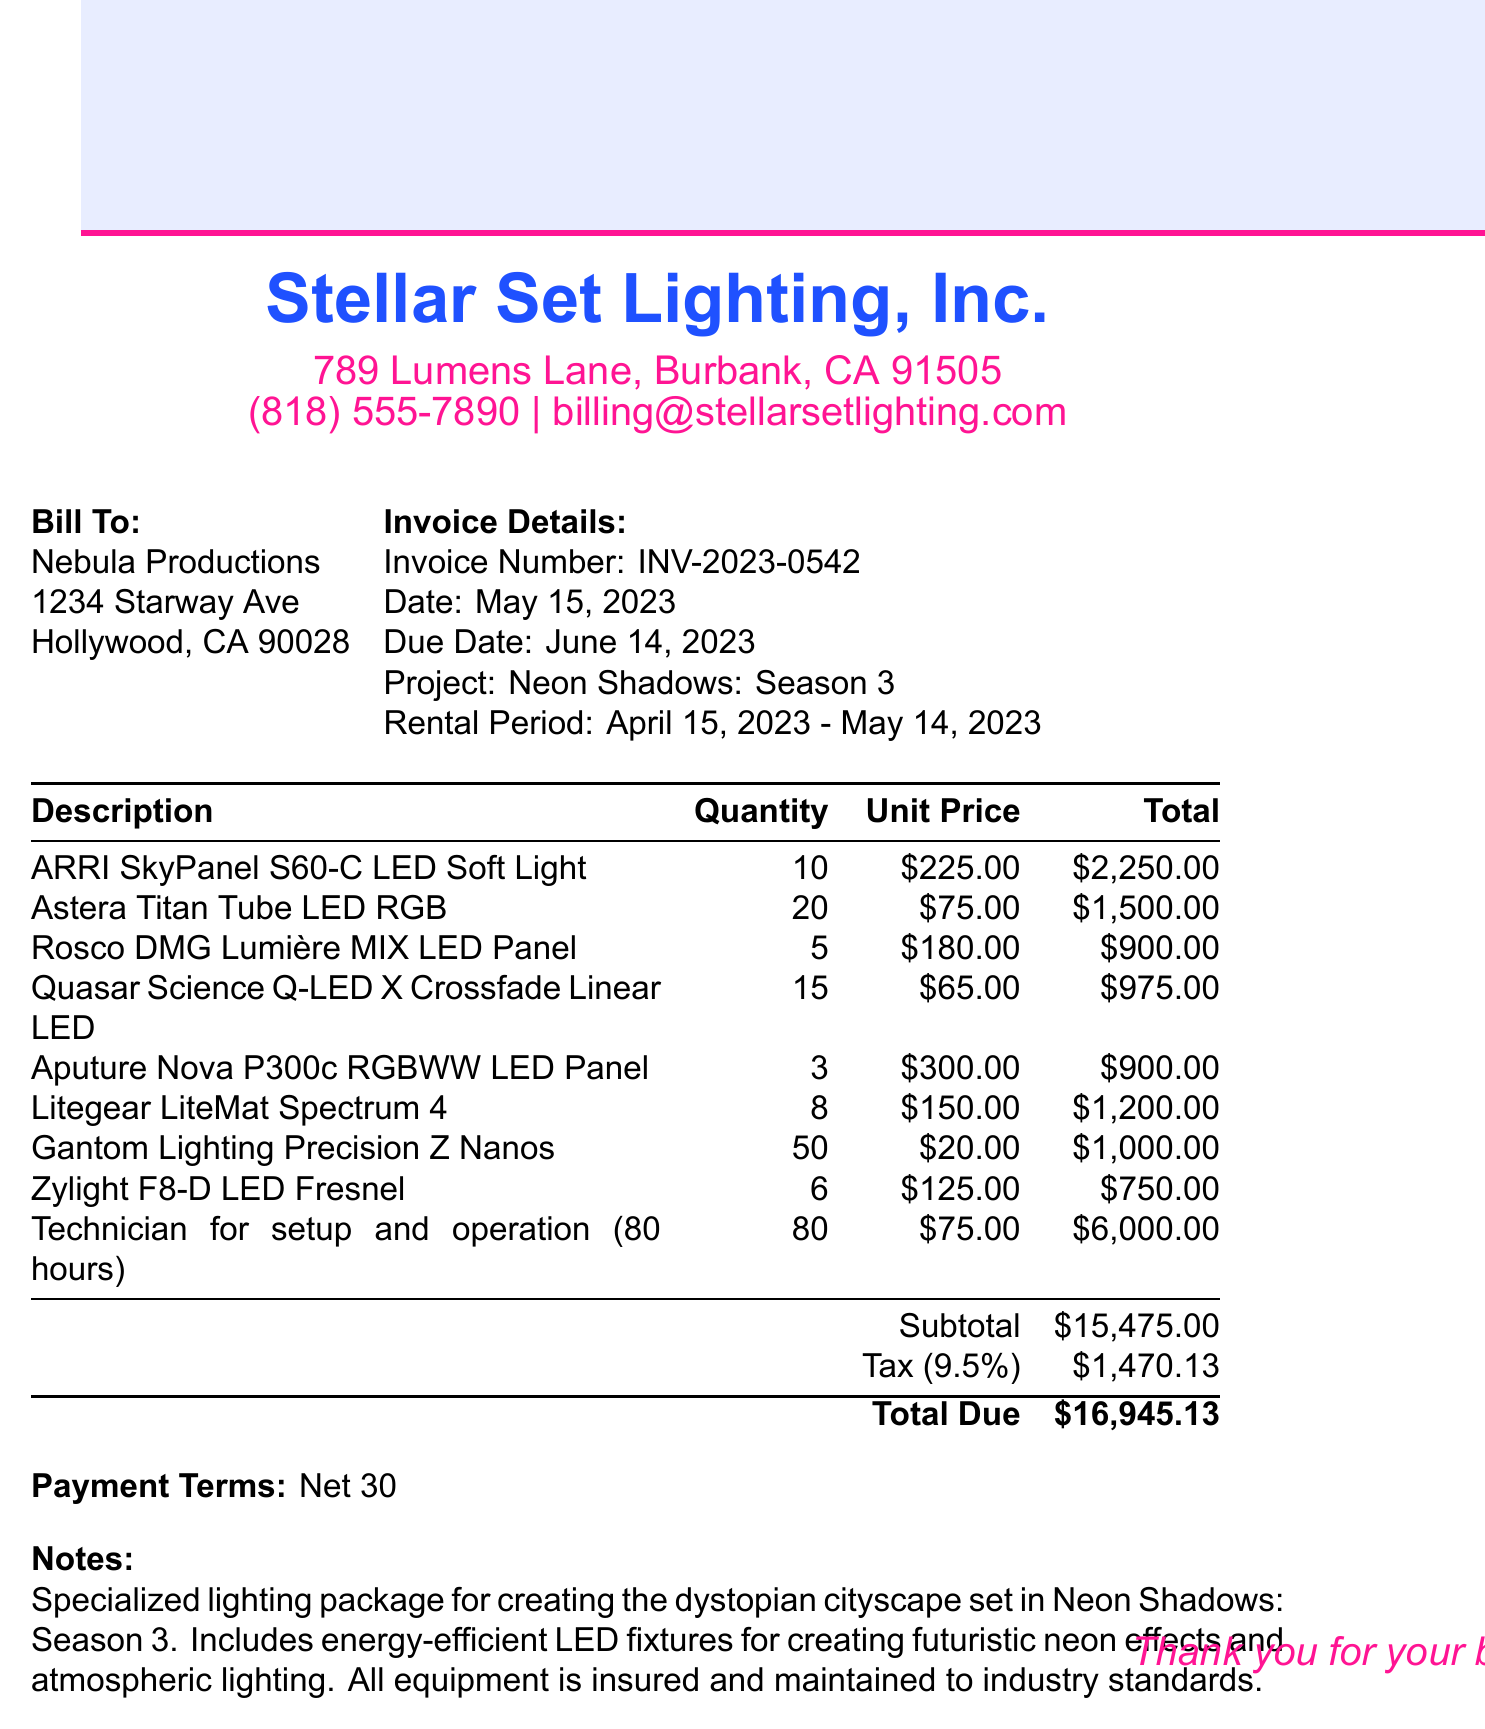What is the invoice number? The invoice number is specified at the top of the document under invoice details.
Answer: INV-2023-0542 What is the total amount due? The total amount due is listed at the bottom of the invoice after the calculations for subtotal and tax.
Answer: $16,945.13 Who is the client for this invoice? The client name is mentioned in the "Bill To" section of the document.
Answer: Nebula Productions What date is the invoice issued? The issue date is specified in the invoice details section.
Answer: May 15, 2023 What is the tax rate applied? The tax rate is indicated in the breakdown of charges on the invoice.
Answer: 9.5% How many units of Astera Titan Tube LED RGB were rented? The quantity for Astera Titan Tube LED RGB is listed in the itemized section of the document.
Answer: 20 How many hours of technician setup and operation were billed? The number of hours for technician setup and operation is detailed in the itemized list under that description.
Answer: 80 hours What is the rental period for the equipment? The rental period is clearly stated in the invoice details section.
Answer: April 15, 2023 - May 14, 2023 What are the payment terms? The payment terms are specified at the bottom of the document.
Answer: Net 30 